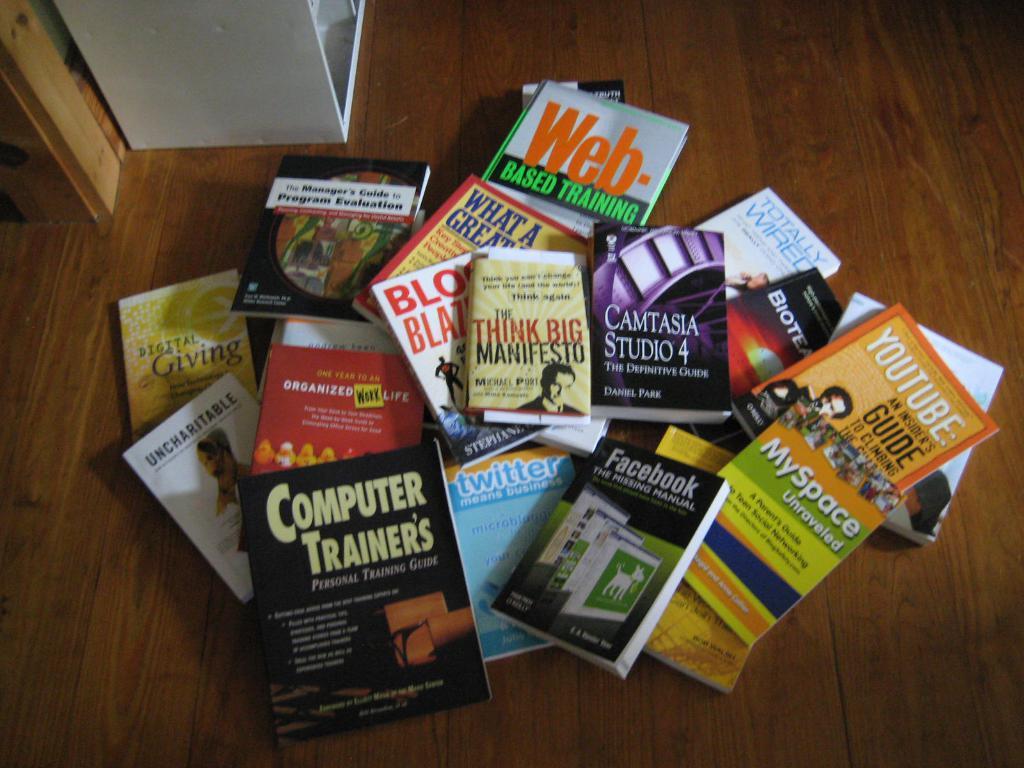Is this person training for computers?
Give a very brief answer. Yes. What comes after "think big"?
Ensure brevity in your answer.  Manifesto. 